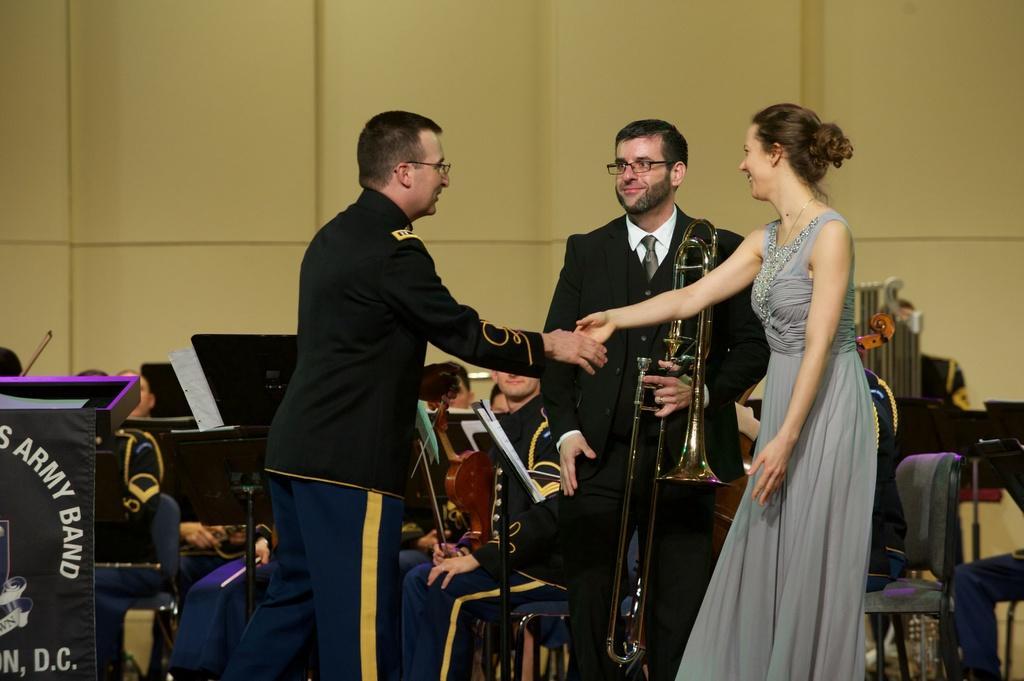Can you describe this image briefly? In this image we can see a woman wearing the frock and smiling and also standing. We can also see a man holding the musical instruments. There is a man standing. In the background, we can see the people with the musical instruments and sitting on the chairs. We can also see the banner with the text. In the background, we can see the wall. Image also consists of some stands with the papers. 